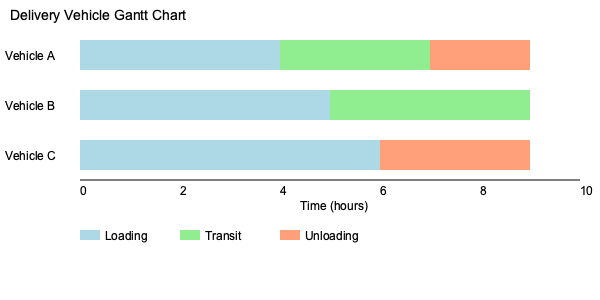Based on the Gantt chart for multiple delivery vehicles, calculate the total idle time for all vehicles combined. Assume that vehicles are considered idle when they are not loading, in transit, or unloading. To solve this problem, we need to follow these steps:

1. Identify the total operational time for each vehicle:
   Vehicle A: $10$ hours (from 0 to 10)
   Vehicle B: $9$ hours (from 0 to 9)
   Vehicle C: $9$ hours (from 0 to 9)

2. Calculate the active time for each vehicle:
   Vehicle A: $2 + 1.5 + 1 = 4.5$ hours
   Vehicle B: $2.5 + 2 = 4.5$ hours
   Vehicle C: $3 + 1.5 = 4.5$ hours

3. Calculate the idle time for each vehicle:
   Vehicle A: $10 - 4.5 = 5.5$ hours
   Vehicle B: $9 - 4.5 = 4.5$ hours
   Vehicle C: $9 - 4.5 = 4.5$ hours

4. Sum up the total idle time:
   Total idle time = $5.5 + 4.5 + 4.5 = 14.5$ hours

Therefore, the total idle time for all vehicles combined is 14.5 hours.
Answer: 14.5 hours 